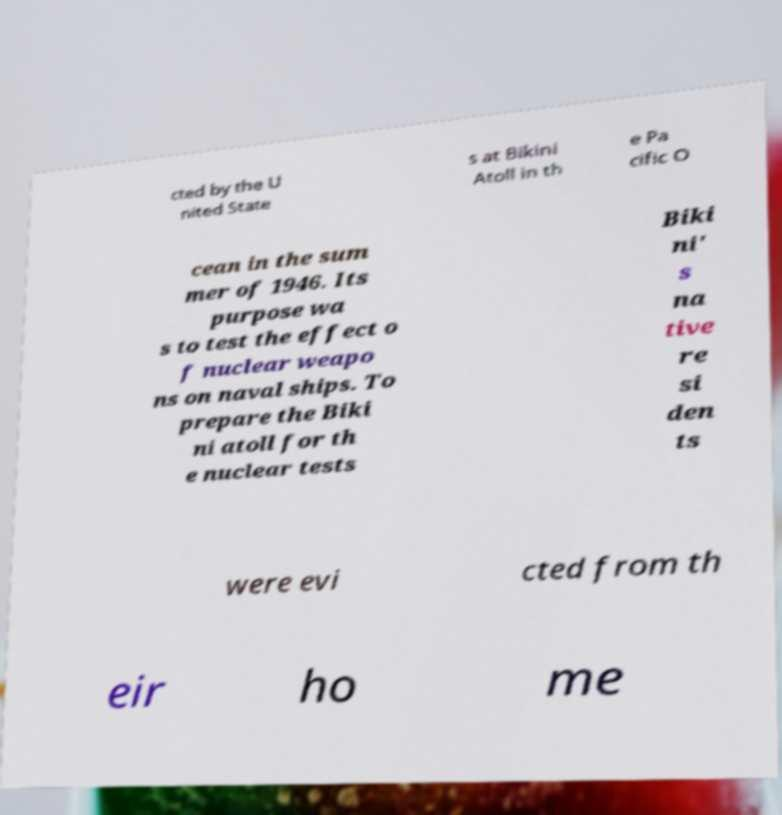I need the written content from this picture converted into text. Can you do that? cted by the U nited State s at Bikini Atoll in th e Pa cific O cean in the sum mer of 1946. Its purpose wa s to test the effect o f nuclear weapo ns on naval ships. To prepare the Biki ni atoll for th e nuclear tests Biki ni' s na tive re si den ts were evi cted from th eir ho me 